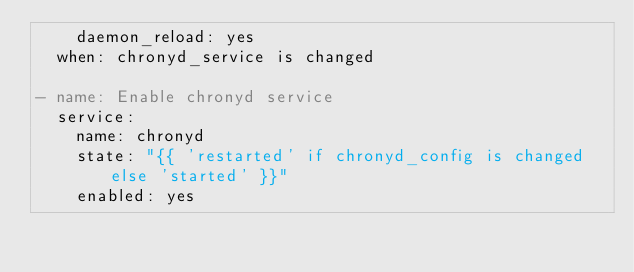<code> <loc_0><loc_0><loc_500><loc_500><_YAML_>    daemon_reload: yes
  when: chronyd_service is changed

- name: Enable chronyd service
  service:
    name: chronyd
    state: "{{ 'restarted' if chronyd_config is changed else 'started' }}"
    enabled: yes
</code> 